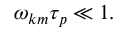<formula> <loc_0><loc_0><loc_500><loc_500>\begin{array} { r } { \omega _ { k m } \tau _ { p } \ll 1 . } \end{array}</formula> 